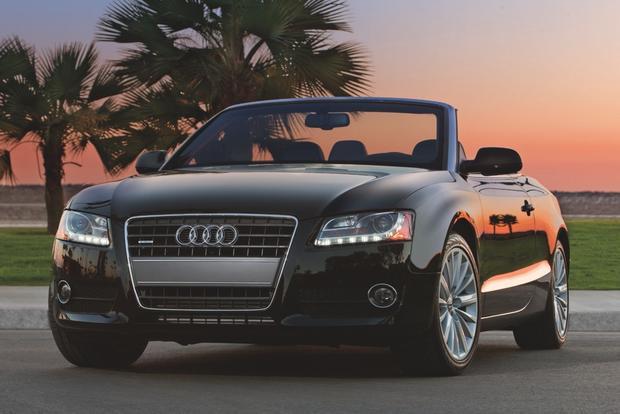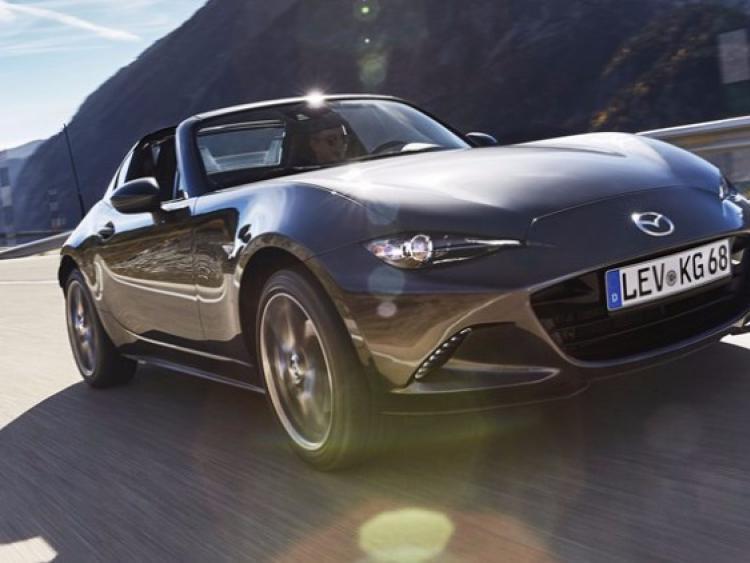The first image is the image on the left, the second image is the image on the right. Assess this claim about the two images: "Each image contains one forward-angled car with its top down and a driver behind the wheel.". Correct or not? Answer yes or no. No. The first image is the image on the left, the second image is the image on the right. Analyze the images presented: Is the assertion "The silver convertibles in these images are currently being driven and are not parked." valid? Answer yes or no. No. 